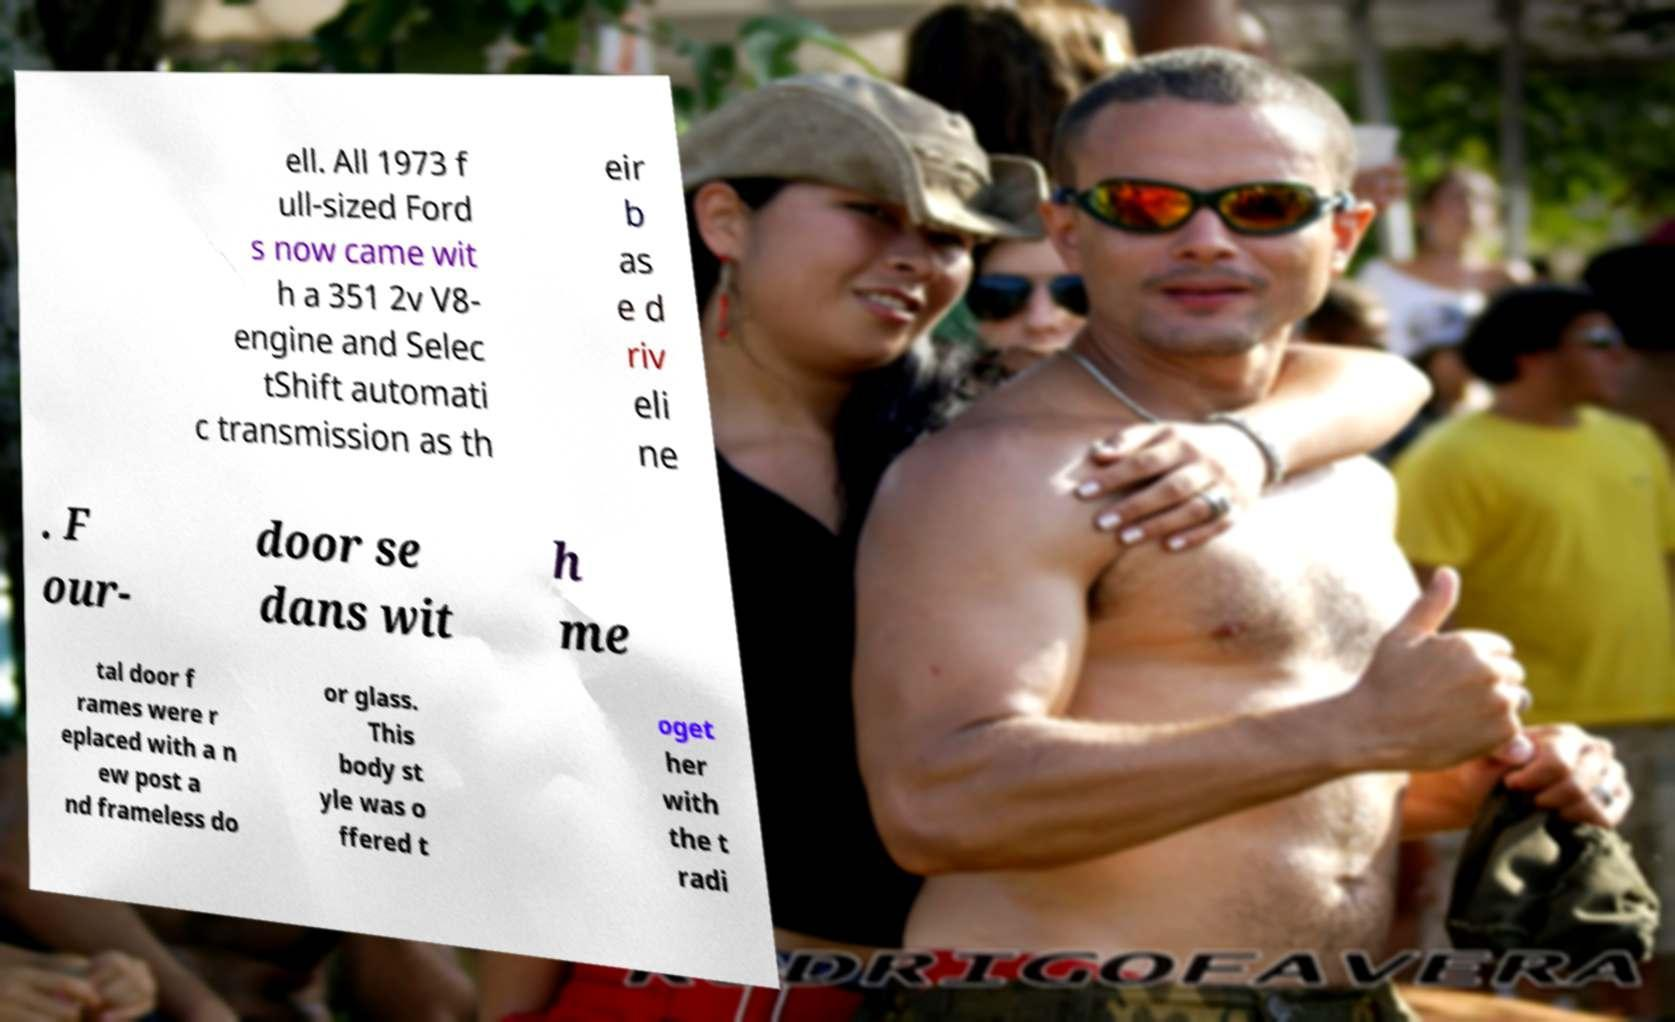For documentation purposes, I need the text within this image transcribed. Could you provide that? ell. All 1973 f ull-sized Ford s now came wit h a 351 2v V8- engine and Selec tShift automati c transmission as th eir b as e d riv eli ne . F our- door se dans wit h me tal door f rames were r eplaced with a n ew post a nd frameless do or glass. This body st yle was o ffered t oget her with the t radi 